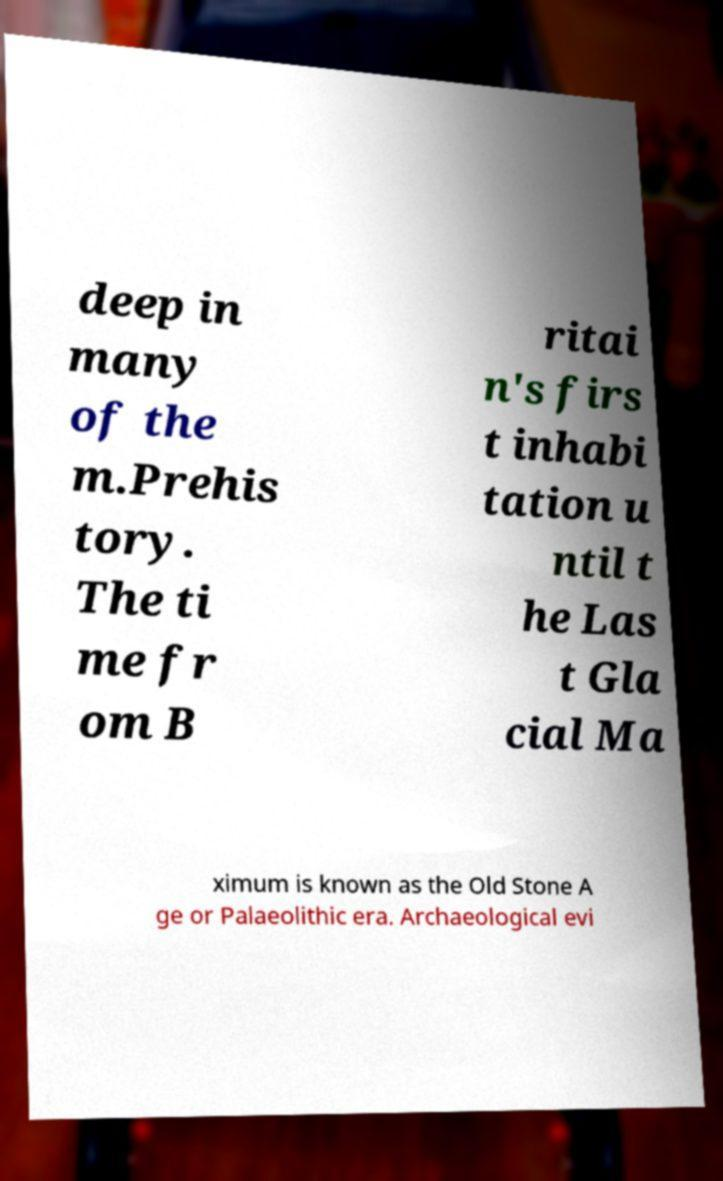Could you extract and type out the text from this image? deep in many of the m.Prehis tory. The ti me fr om B ritai n's firs t inhabi tation u ntil t he Las t Gla cial Ma ximum is known as the Old Stone A ge or Palaeolithic era. Archaeological evi 